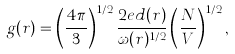<formula> <loc_0><loc_0><loc_500><loc_500>g ( r ) = \left ( \frac { 4 \pi } { 3 } \right ) ^ { 1 / 2 } \frac { 2 e d ( r ) } { \omega ( r ) ^ { 1 / 2 } } \left ( \frac { N } { V } \right ) ^ { 1 / 2 } ,</formula> 